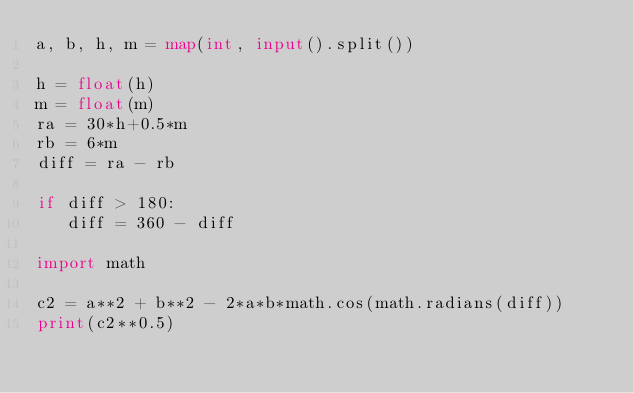<code> <loc_0><loc_0><loc_500><loc_500><_Python_>a, b, h, m = map(int, input().split())

h = float(h)
m = float(m)
ra = 30*h+0.5*m
rb = 6*m
diff = ra - rb

if diff > 180:
   diff = 360 - diff

import math

c2 = a**2 + b**2 - 2*a*b*math.cos(math.radians(diff))
print(c2**0.5)
</code> 